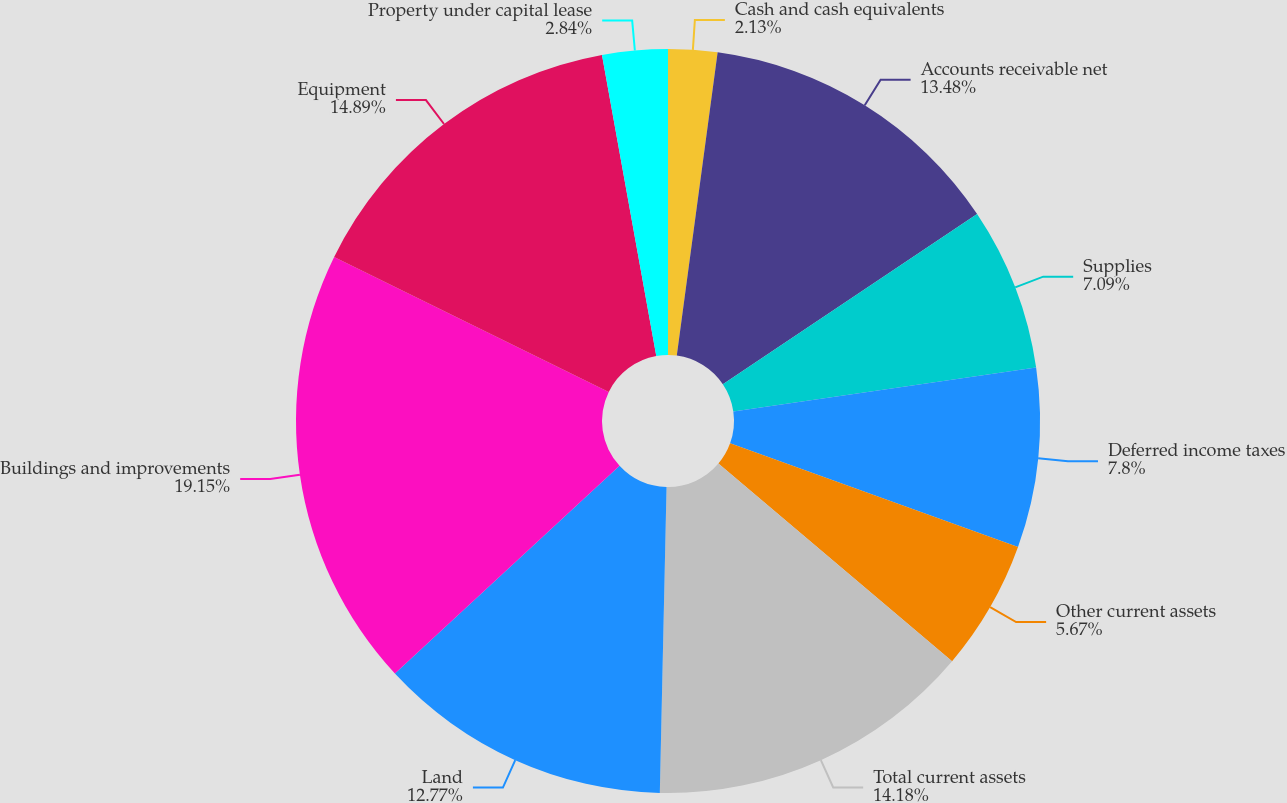Convert chart to OTSL. <chart><loc_0><loc_0><loc_500><loc_500><pie_chart><fcel>Cash and cash equivalents<fcel>Accounts receivable net<fcel>Supplies<fcel>Deferred income taxes<fcel>Other current assets<fcel>Total current assets<fcel>Land<fcel>Buildings and improvements<fcel>Equipment<fcel>Property under capital lease<nl><fcel>2.13%<fcel>13.48%<fcel>7.09%<fcel>7.8%<fcel>5.67%<fcel>14.18%<fcel>12.77%<fcel>19.15%<fcel>14.89%<fcel>2.84%<nl></chart> 